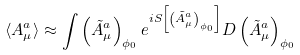Convert formula to latex. <formula><loc_0><loc_0><loc_500><loc_500>\langle A ^ { a } _ { \mu } \rangle \approx \int \left ( \tilde { A } ^ { a } _ { \mu } \right ) _ { \phi _ { 0 } } e ^ { i S \left [ \left ( \tilde { A } ^ { a } _ { \mu } \right ) _ { \phi _ { 0 } } \right ] } D \left ( \tilde { A } ^ { a } _ { \mu } \right ) _ { \phi _ { 0 } }</formula> 